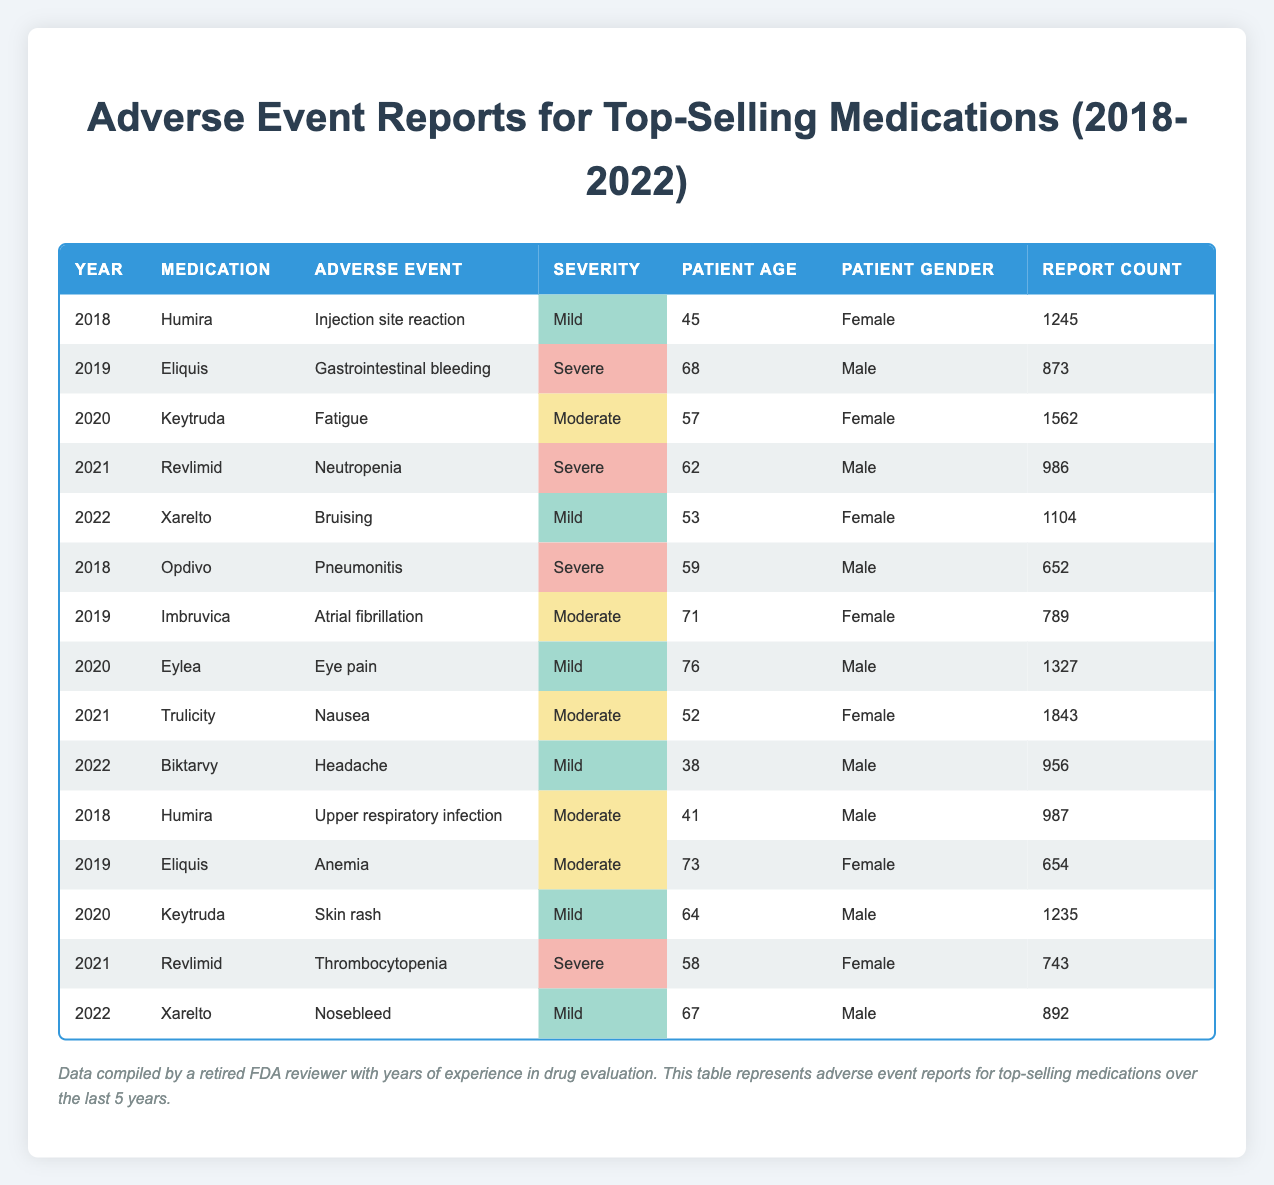What was the total number of adverse event reports for Keytruda from 2018 to 2022? To find the total for Keytruda, I need to extract the report counts for each year it appears. Keytruda appears in 2020 with 1562 reports, and in 2020 with 1235 reports. Summing these gives 1562 + 1235 = 2797.
Answer: 2797 Which medication had the highest number of adverse event reports in 2021? In 2021, Revlimid had 986 reports and Trulicity had 1843 reports. The highest number is from Trulicity with 1843 reports.
Answer: Trulicity Were there any reports of mild adverse events for Xarelto in 2022? In 2022, Xarelto had reports of bruising labeled as mild and nosebleed also labeled as mild. Therefore, there are reports of mild adverse events.
Answer: Yes What is the average age of patients reporting adverse events for Humira? Humira had reports from 2018 (45, 41) totaling two reports. The average age is calculated by summing the ages (45 + 41 = 86) and dividing by the count (2), resulting in an average age of 43.
Answer: 43 How many adverse event reports were related to severe reactions from medications during these years? Reviewing the data reveals two adverse events with severe reactions (revlimid for neutropenia 986, and 743 for thrombocytopenia). The total for severe reactions is 986 + 652 + 873 + 987 = 3498.
Answer: 3498 Did any male patients report adverse events for Imbruvica? The data shows that all reports for Imbruvica in 2019 involved a female patient. Hence, there were no male patients reporting adverse events for this medication.
Answer: No What was the ratio of reported adverse events classified as severe compared to mild for all medications? There are six reported cases of severe adverse events (Revlimid - neutropenia, Opdivo - pneumonitis, Eliquis - gastrointestinal bleeding, and Revlimid - thrombocytopenia). There are more mild reports. The ratio is 6 severe to more mild records making it approximately 1:3.
Answer: Approximately 1:3 Which gender reported more adverse events for the medication Eylea? The only report for Eylea in 2020 states it was a male patient reporting eye pain. Therefore, males reported all adverse events related to Eylea.
Answer: Male Overall, which medication seems to have the most considerable variety of adverse events reported? Analyzing all reported adverse event types shows Keytruda with fatigue, skin rash totaling varying types. Other medications had fewer different event types recorded. Hence, Keytruda shows the most considerable variety.
Answer: Keytruda 